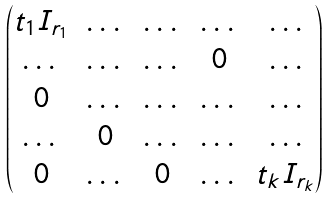<formula> <loc_0><loc_0><loc_500><loc_500>\begin{pmatrix} t _ { 1 } I _ { r _ { 1 } } & \dots & \dots & \dots & \dots \\ \dots & \dots & \dots & 0 & \dots \\ 0 & \dots & \dots & \dots & \dots \\ \dots & 0 & \dots & \dots & \dots \\ 0 & \dots & 0 & \dots & t _ { k } I _ { r _ { k } } \end{pmatrix}</formula> 